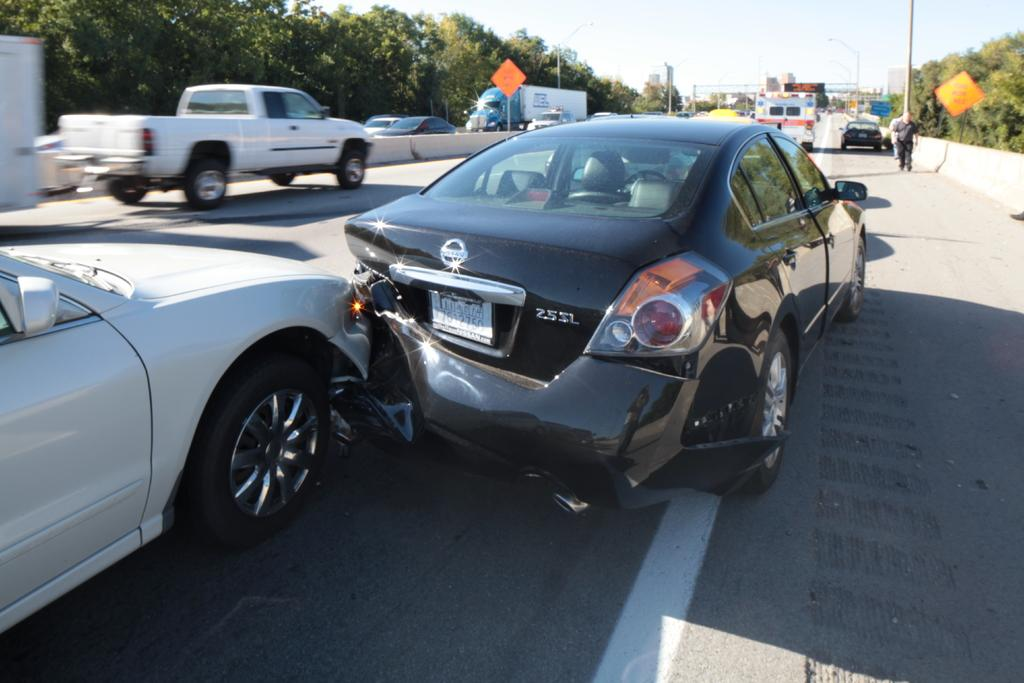What event has occurred involving vehicles in the image? Two vehicles have collided in the image. What is happening with the other vehicles in the image? There are other vehicles moving on the road in the image. What can be seen in the background of the image? There are many trees visible in the background of the image. How does the bubble affect the movement of the vehicles in the image? There is no bubble present in the image, so it does not affect the movement of the vehicles. 